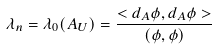<formula> <loc_0><loc_0><loc_500><loc_500>\lambda _ { n } = \lambda _ { 0 } ( A _ { U } ) = \frac { < d _ { A } \phi , d _ { A } \phi > } { ( \phi , \phi ) }</formula> 